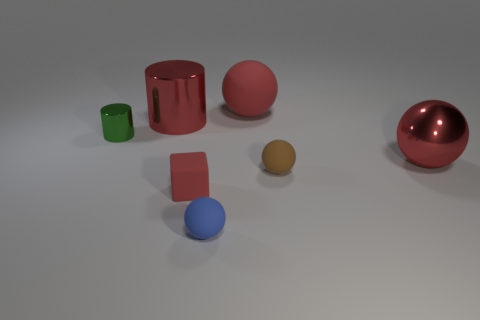What number of metal things are big objects or blocks?
Give a very brief answer. 2. Is the shape of the red metal thing that is behind the tiny green metallic thing the same as  the small brown rubber thing?
Offer a very short reply. No. Is the number of big red spheres that are to the right of the large red rubber object greater than the number of tiny brown cubes?
Keep it short and to the point. Yes. How many big red things are both on the left side of the metal ball and right of the tiny blue object?
Provide a succinct answer. 1. The cylinder that is to the left of the large red object left of the blue ball is what color?
Offer a terse response. Green. What number of tiny blocks have the same color as the large metal ball?
Give a very brief answer. 1. There is a small rubber cube; does it have the same color as the big ball behind the big cylinder?
Give a very brief answer. Yes. Are there fewer large purple cubes than cubes?
Offer a terse response. Yes. Is the number of big balls in front of the small green cylinder greater than the number of tiny brown matte objects that are in front of the tiny brown ball?
Give a very brief answer. Yes. Do the tiny brown ball and the blue sphere have the same material?
Ensure brevity in your answer.  Yes. 